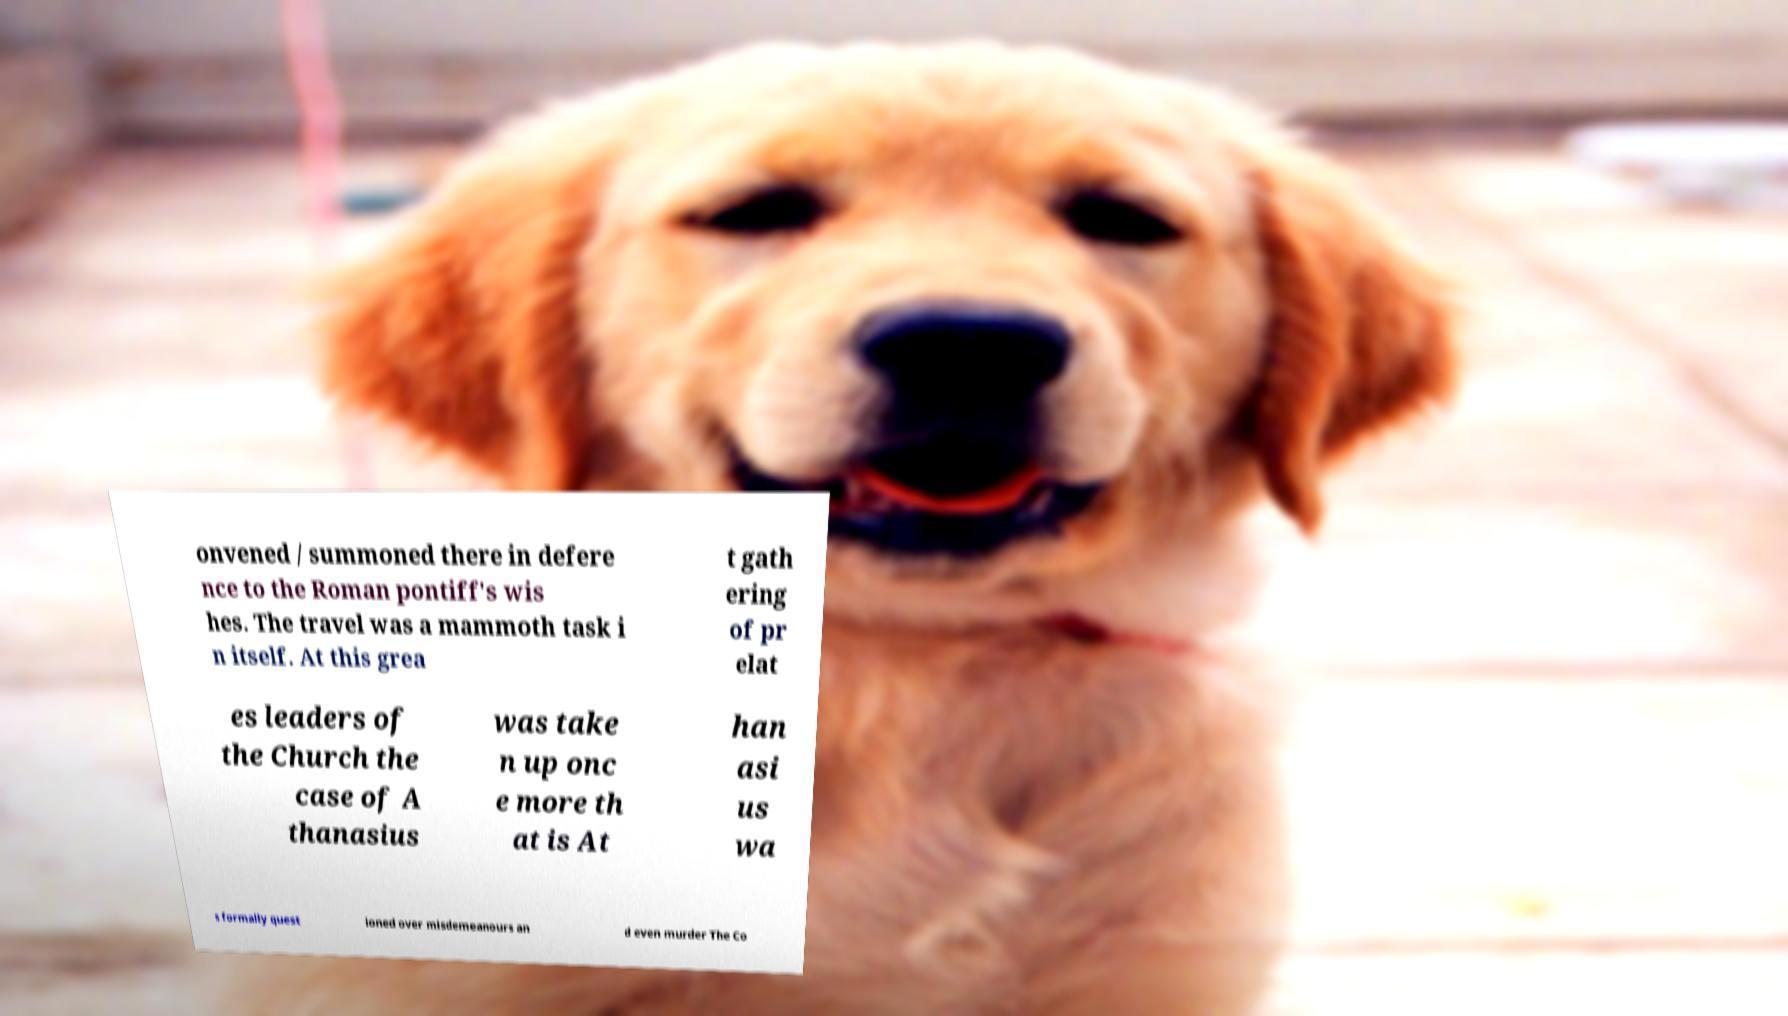Can you read and provide the text displayed in the image?This photo seems to have some interesting text. Can you extract and type it out for me? onvened / summoned there in defere nce to the Roman pontiff's wis hes. The travel was a mammoth task i n itself. At this grea t gath ering of pr elat es leaders of the Church the case of A thanasius was take n up onc e more th at is At han asi us wa s formally quest ioned over misdemeanours an d even murder The Co 